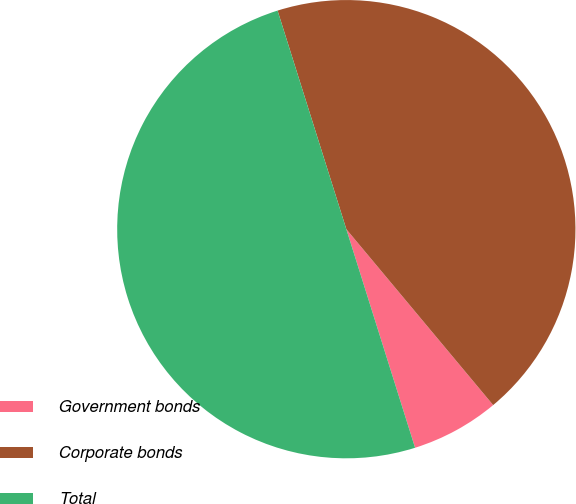Convert chart to OTSL. <chart><loc_0><loc_0><loc_500><loc_500><pie_chart><fcel>Government bonds<fcel>Corporate bonds<fcel>Total<nl><fcel>6.22%<fcel>43.78%<fcel>50.0%<nl></chart> 